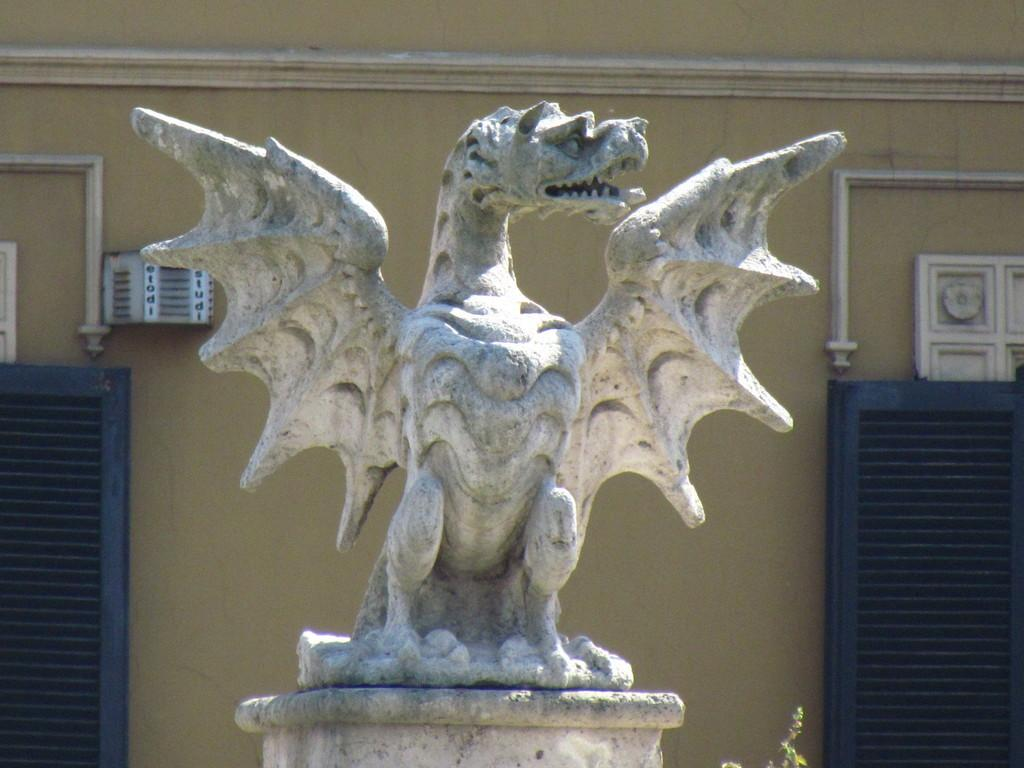What is the main subject of the image? There is a statue in the image. What material is the statue made of? The statue is carved on stone. What can be seen in the background of the image? There is a wall and windows in the background of the image. How many trees are visible in the image? There are no trees visible in the image; it only features a statue, a wall, and windows. What type of punishment is being depicted in the image? There is no punishment being depicted in the image; it only features a statue carved on stone. 